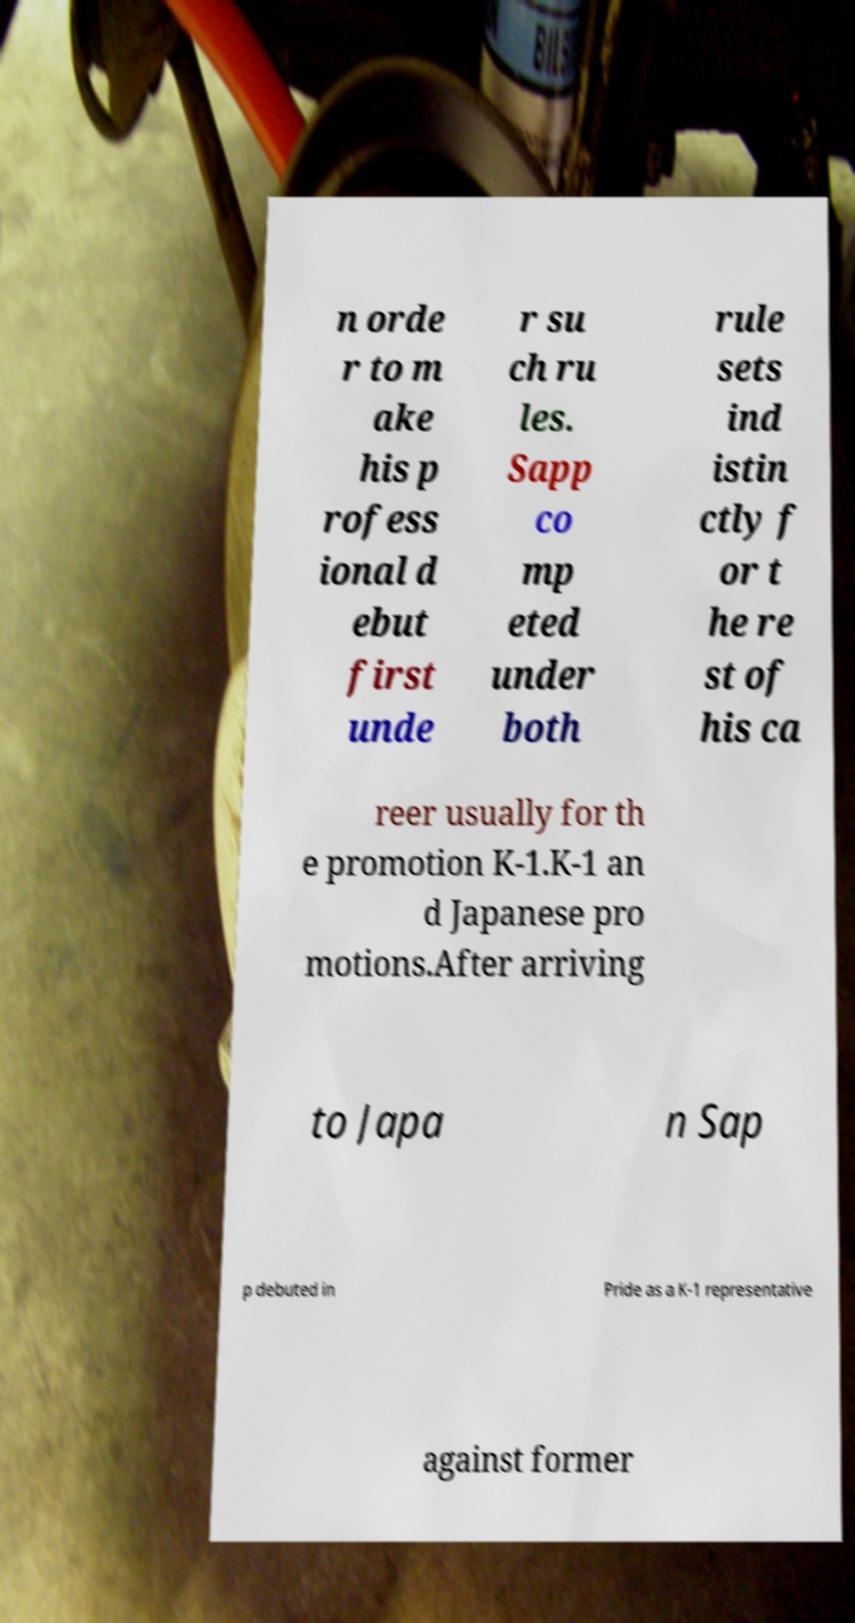Could you extract and type out the text from this image? n orde r to m ake his p rofess ional d ebut first unde r su ch ru les. Sapp co mp eted under both rule sets ind istin ctly f or t he re st of his ca reer usually for th e promotion K-1.K-1 an d Japanese pro motions.After arriving to Japa n Sap p debuted in Pride as a K-1 representative against former 